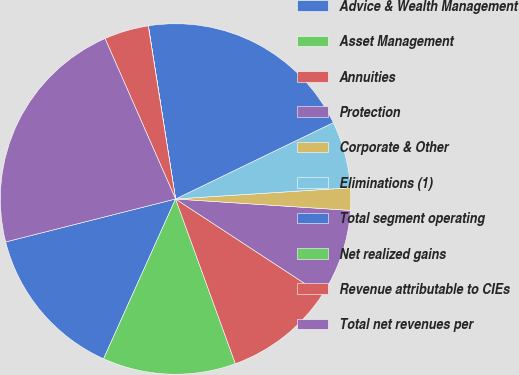Convert chart to OTSL. <chart><loc_0><loc_0><loc_500><loc_500><pie_chart><fcel>Advice & Wealth Management<fcel>Asset Management<fcel>Annuities<fcel>Protection<fcel>Corporate & Other<fcel>Eliminations (1)<fcel>Total segment operating<fcel>Net realized gains<fcel>Revenue attributable to CIEs<fcel>Total net revenues per<nl><fcel>14.32%<fcel>12.28%<fcel>10.23%<fcel>8.19%<fcel>2.06%<fcel>6.15%<fcel>20.31%<fcel>0.01%<fcel>4.1%<fcel>22.35%<nl></chart> 